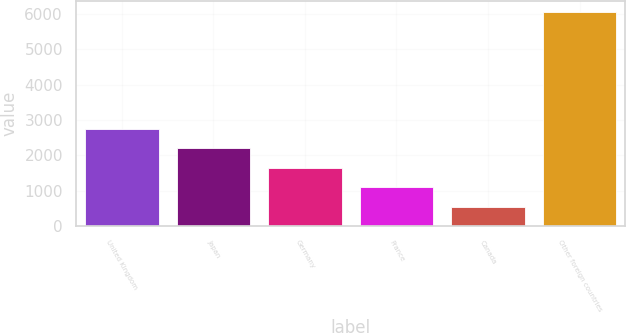Convert chart to OTSL. <chart><loc_0><loc_0><loc_500><loc_500><bar_chart><fcel>United Kingdom<fcel>Japan<fcel>Germany<fcel>France<fcel>Canada<fcel>Other foreign countries<nl><fcel>2754.8<fcel>2203.1<fcel>1651.4<fcel>1099.7<fcel>548<fcel>6065<nl></chart> 